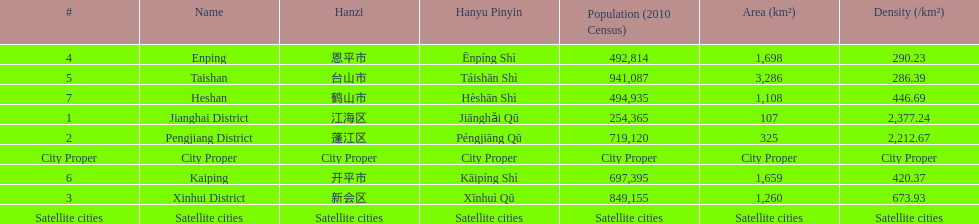Is enping more/less dense than kaiping? Less. 